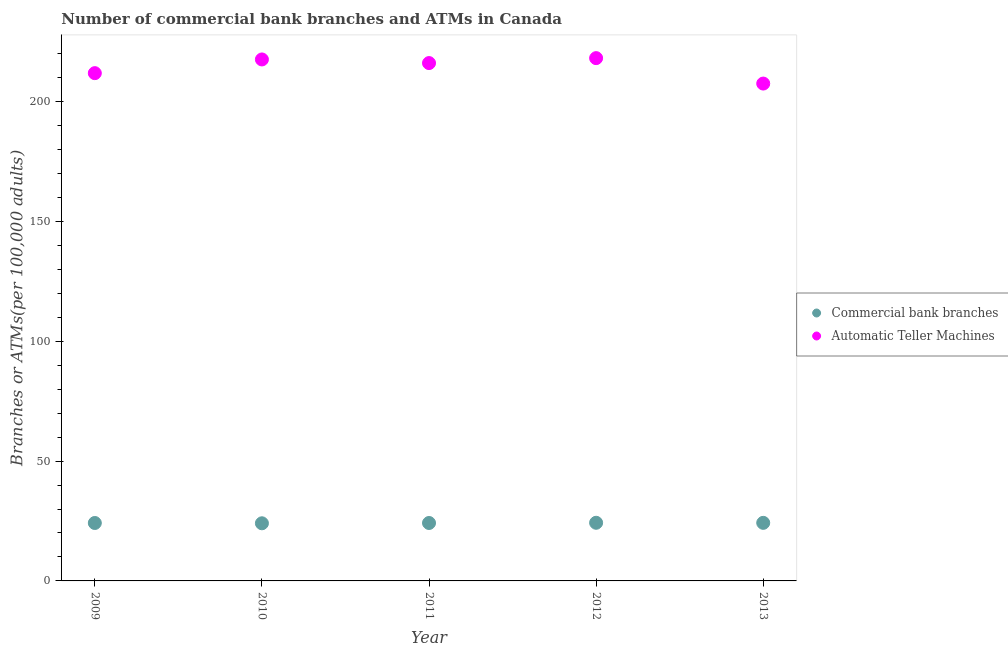How many different coloured dotlines are there?
Your answer should be compact. 2. Is the number of dotlines equal to the number of legend labels?
Your response must be concise. Yes. What is the number of atms in 2012?
Make the answer very short. 218.18. Across all years, what is the maximum number of commercal bank branches?
Make the answer very short. 24.27. Across all years, what is the minimum number of commercal bank branches?
Keep it short and to the point. 24.05. In which year was the number of commercal bank branches maximum?
Offer a very short reply. 2012. In which year was the number of commercal bank branches minimum?
Keep it short and to the point. 2010. What is the total number of commercal bank branches in the graph?
Make the answer very short. 120.91. What is the difference between the number of commercal bank branches in 2011 and that in 2013?
Your answer should be very brief. -0.06. What is the difference between the number of commercal bank branches in 2012 and the number of atms in 2009?
Provide a short and direct response. -187.64. What is the average number of commercal bank branches per year?
Give a very brief answer. 24.18. In the year 2009, what is the difference between the number of commercal bank branches and number of atms?
Your answer should be very brief. -187.73. In how many years, is the number of atms greater than 210?
Make the answer very short. 4. What is the ratio of the number of atms in 2010 to that in 2013?
Provide a succinct answer. 1.05. What is the difference between the highest and the second highest number of commercal bank branches?
Give a very brief answer. 0.03. What is the difference between the highest and the lowest number of atms?
Your response must be concise. 10.61. Is the number of commercal bank branches strictly greater than the number of atms over the years?
Provide a succinct answer. No. Is the number of commercal bank branches strictly less than the number of atms over the years?
Keep it short and to the point. Yes. Does the graph contain any zero values?
Your answer should be very brief. No. Where does the legend appear in the graph?
Provide a short and direct response. Center right. How many legend labels are there?
Keep it short and to the point. 2. What is the title of the graph?
Provide a short and direct response. Number of commercial bank branches and ATMs in Canada. Does "Highest 10% of population" appear as one of the legend labels in the graph?
Offer a very short reply. No. What is the label or title of the Y-axis?
Your response must be concise. Branches or ATMs(per 100,0 adults). What is the Branches or ATMs(per 100,000 adults) of Commercial bank branches in 2009?
Your answer should be very brief. 24.18. What is the Branches or ATMs(per 100,000 adults) of Automatic Teller Machines in 2009?
Keep it short and to the point. 211.91. What is the Branches or ATMs(per 100,000 adults) in Commercial bank branches in 2010?
Offer a terse response. 24.05. What is the Branches or ATMs(per 100,000 adults) in Automatic Teller Machines in 2010?
Your answer should be compact. 217.63. What is the Branches or ATMs(per 100,000 adults) in Commercial bank branches in 2011?
Ensure brevity in your answer.  24.18. What is the Branches or ATMs(per 100,000 adults) in Automatic Teller Machines in 2011?
Offer a terse response. 216.11. What is the Branches or ATMs(per 100,000 adults) of Commercial bank branches in 2012?
Your response must be concise. 24.27. What is the Branches or ATMs(per 100,000 adults) of Automatic Teller Machines in 2012?
Give a very brief answer. 218.18. What is the Branches or ATMs(per 100,000 adults) in Commercial bank branches in 2013?
Offer a terse response. 24.24. What is the Branches or ATMs(per 100,000 adults) in Automatic Teller Machines in 2013?
Provide a short and direct response. 207.56. Across all years, what is the maximum Branches or ATMs(per 100,000 adults) of Commercial bank branches?
Your answer should be compact. 24.27. Across all years, what is the maximum Branches or ATMs(per 100,000 adults) of Automatic Teller Machines?
Provide a short and direct response. 218.18. Across all years, what is the minimum Branches or ATMs(per 100,000 adults) of Commercial bank branches?
Make the answer very short. 24.05. Across all years, what is the minimum Branches or ATMs(per 100,000 adults) of Automatic Teller Machines?
Your answer should be compact. 207.56. What is the total Branches or ATMs(per 100,000 adults) of Commercial bank branches in the graph?
Ensure brevity in your answer.  120.91. What is the total Branches or ATMs(per 100,000 adults) of Automatic Teller Machines in the graph?
Your answer should be compact. 1071.39. What is the difference between the Branches or ATMs(per 100,000 adults) in Commercial bank branches in 2009 and that in 2010?
Offer a terse response. 0.12. What is the difference between the Branches or ATMs(per 100,000 adults) in Automatic Teller Machines in 2009 and that in 2010?
Provide a succinct answer. -5.72. What is the difference between the Branches or ATMs(per 100,000 adults) of Commercial bank branches in 2009 and that in 2011?
Make the answer very short. 0. What is the difference between the Branches or ATMs(per 100,000 adults) in Automatic Teller Machines in 2009 and that in 2011?
Your response must be concise. -4.21. What is the difference between the Branches or ATMs(per 100,000 adults) in Commercial bank branches in 2009 and that in 2012?
Keep it short and to the point. -0.09. What is the difference between the Branches or ATMs(per 100,000 adults) in Automatic Teller Machines in 2009 and that in 2012?
Keep it short and to the point. -6.27. What is the difference between the Branches or ATMs(per 100,000 adults) of Commercial bank branches in 2009 and that in 2013?
Give a very brief answer. -0.06. What is the difference between the Branches or ATMs(per 100,000 adults) of Automatic Teller Machines in 2009 and that in 2013?
Give a very brief answer. 4.34. What is the difference between the Branches or ATMs(per 100,000 adults) of Commercial bank branches in 2010 and that in 2011?
Your response must be concise. -0.12. What is the difference between the Branches or ATMs(per 100,000 adults) in Automatic Teller Machines in 2010 and that in 2011?
Make the answer very short. 1.51. What is the difference between the Branches or ATMs(per 100,000 adults) of Commercial bank branches in 2010 and that in 2012?
Your answer should be very brief. -0.21. What is the difference between the Branches or ATMs(per 100,000 adults) of Automatic Teller Machines in 2010 and that in 2012?
Provide a short and direct response. -0.55. What is the difference between the Branches or ATMs(per 100,000 adults) of Commercial bank branches in 2010 and that in 2013?
Make the answer very short. -0.18. What is the difference between the Branches or ATMs(per 100,000 adults) in Automatic Teller Machines in 2010 and that in 2013?
Give a very brief answer. 10.06. What is the difference between the Branches or ATMs(per 100,000 adults) of Commercial bank branches in 2011 and that in 2012?
Provide a short and direct response. -0.09. What is the difference between the Branches or ATMs(per 100,000 adults) of Automatic Teller Machines in 2011 and that in 2012?
Offer a terse response. -2.06. What is the difference between the Branches or ATMs(per 100,000 adults) in Commercial bank branches in 2011 and that in 2013?
Offer a terse response. -0.06. What is the difference between the Branches or ATMs(per 100,000 adults) of Automatic Teller Machines in 2011 and that in 2013?
Provide a succinct answer. 8.55. What is the difference between the Branches or ATMs(per 100,000 adults) in Commercial bank branches in 2012 and that in 2013?
Provide a short and direct response. 0.03. What is the difference between the Branches or ATMs(per 100,000 adults) in Automatic Teller Machines in 2012 and that in 2013?
Provide a short and direct response. 10.61. What is the difference between the Branches or ATMs(per 100,000 adults) in Commercial bank branches in 2009 and the Branches or ATMs(per 100,000 adults) in Automatic Teller Machines in 2010?
Offer a very short reply. -193.45. What is the difference between the Branches or ATMs(per 100,000 adults) in Commercial bank branches in 2009 and the Branches or ATMs(per 100,000 adults) in Automatic Teller Machines in 2011?
Provide a short and direct response. -191.94. What is the difference between the Branches or ATMs(per 100,000 adults) of Commercial bank branches in 2009 and the Branches or ATMs(per 100,000 adults) of Automatic Teller Machines in 2012?
Keep it short and to the point. -194. What is the difference between the Branches or ATMs(per 100,000 adults) in Commercial bank branches in 2009 and the Branches or ATMs(per 100,000 adults) in Automatic Teller Machines in 2013?
Ensure brevity in your answer.  -183.39. What is the difference between the Branches or ATMs(per 100,000 adults) of Commercial bank branches in 2010 and the Branches or ATMs(per 100,000 adults) of Automatic Teller Machines in 2011?
Provide a succinct answer. -192.06. What is the difference between the Branches or ATMs(per 100,000 adults) in Commercial bank branches in 2010 and the Branches or ATMs(per 100,000 adults) in Automatic Teller Machines in 2012?
Make the answer very short. -194.12. What is the difference between the Branches or ATMs(per 100,000 adults) of Commercial bank branches in 2010 and the Branches or ATMs(per 100,000 adults) of Automatic Teller Machines in 2013?
Offer a very short reply. -183.51. What is the difference between the Branches or ATMs(per 100,000 adults) in Commercial bank branches in 2011 and the Branches or ATMs(per 100,000 adults) in Automatic Teller Machines in 2012?
Ensure brevity in your answer.  -194. What is the difference between the Branches or ATMs(per 100,000 adults) of Commercial bank branches in 2011 and the Branches or ATMs(per 100,000 adults) of Automatic Teller Machines in 2013?
Your response must be concise. -183.39. What is the difference between the Branches or ATMs(per 100,000 adults) of Commercial bank branches in 2012 and the Branches or ATMs(per 100,000 adults) of Automatic Teller Machines in 2013?
Your response must be concise. -183.3. What is the average Branches or ATMs(per 100,000 adults) in Commercial bank branches per year?
Give a very brief answer. 24.18. What is the average Branches or ATMs(per 100,000 adults) of Automatic Teller Machines per year?
Provide a short and direct response. 214.28. In the year 2009, what is the difference between the Branches or ATMs(per 100,000 adults) in Commercial bank branches and Branches or ATMs(per 100,000 adults) in Automatic Teller Machines?
Your response must be concise. -187.73. In the year 2010, what is the difference between the Branches or ATMs(per 100,000 adults) in Commercial bank branches and Branches or ATMs(per 100,000 adults) in Automatic Teller Machines?
Ensure brevity in your answer.  -193.57. In the year 2011, what is the difference between the Branches or ATMs(per 100,000 adults) in Commercial bank branches and Branches or ATMs(per 100,000 adults) in Automatic Teller Machines?
Give a very brief answer. -191.94. In the year 2012, what is the difference between the Branches or ATMs(per 100,000 adults) of Commercial bank branches and Branches or ATMs(per 100,000 adults) of Automatic Teller Machines?
Offer a very short reply. -193.91. In the year 2013, what is the difference between the Branches or ATMs(per 100,000 adults) in Commercial bank branches and Branches or ATMs(per 100,000 adults) in Automatic Teller Machines?
Provide a short and direct response. -183.33. What is the ratio of the Branches or ATMs(per 100,000 adults) of Automatic Teller Machines in 2009 to that in 2010?
Keep it short and to the point. 0.97. What is the ratio of the Branches or ATMs(per 100,000 adults) in Commercial bank branches in 2009 to that in 2011?
Provide a succinct answer. 1. What is the ratio of the Branches or ATMs(per 100,000 adults) of Automatic Teller Machines in 2009 to that in 2011?
Offer a very short reply. 0.98. What is the ratio of the Branches or ATMs(per 100,000 adults) of Commercial bank branches in 2009 to that in 2012?
Your answer should be very brief. 1. What is the ratio of the Branches or ATMs(per 100,000 adults) of Automatic Teller Machines in 2009 to that in 2012?
Offer a terse response. 0.97. What is the ratio of the Branches or ATMs(per 100,000 adults) in Commercial bank branches in 2009 to that in 2013?
Keep it short and to the point. 1. What is the ratio of the Branches or ATMs(per 100,000 adults) of Automatic Teller Machines in 2009 to that in 2013?
Your response must be concise. 1.02. What is the ratio of the Branches or ATMs(per 100,000 adults) of Commercial bank branches in 2010 to that in 2011?
Give a very brief answer. 0.99. What is the ratio of the Branches or ATMs(per 100,000 adults) of Commercial bank branches in 2010 to that in 2013?
Your answer should be compact. 0.99. What is the ratio of the Branches or ATMs(per 100,000 adults) of Automatic Teller Machines in 2010 to that in 2013?
Provide a succinct answer. 1.05. What is the ratio of the Branches or ATMs(per 100,000 adults) in Automatic Teller Machines in 2011 to that in 2013?
Provide a succinct answer. 1.04. What is the ratio of the Branches or ATMs(per 100,000 adults) in Automatic Teller Machines in 2012 to that in 2013?
Make the answer very short. 1.05. What is the difference between the highest and the second highest Branches or ATMs(per 100,000 adults) in Commercial bank branches?
Offer a terse response. 0.03. What is the difference between the highest and the second highest Branches or ATMs(per 100,000 adults) in Automatic Teller Machines?
Ensure brevity in your answer.  0.55. What is the difference between the highest and the lowest Branches or ATMs(per 100,000 adults) in Commercial bank branches?
Keep it short and to the point. 0.21. What is the difference between the highest and the lowest Branches or ATMs(per 100,000 adults) in Automatic Teller Machines?
Your response must be concise. 10.61. 